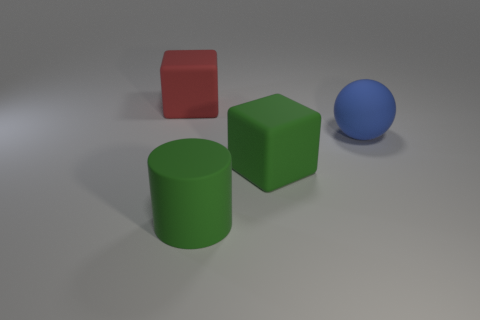What number of blocks are the same color as the large matte cylinder?
Your response must be concise. 1. What number of things are rubber blocks that are right of the red rubber thing or green cubes?
Offer a terse response. 1. What is the color of the ball that is made of the same material as the big green cylinder?
Offer a very short reply. Blue. Is there a cylinder of the same size as the red cube?
Your response must be concise. Yes. What number of things are either large things in front of the big blue rubber ball or big rubber things in front of the red block?
Offer a very short reply. 3. What shape is the green rubber thing that is the same size as the green cube?
Provide a short and direct response. Cylinder. Are there any tiny yellow metal objects that have the same shape as the red thing?
Provide a short and direct response. No. Are there fewer tiny spheres than big matte cubes?
Your answer should be compact. Yes. Is the size of the matte cube that is behind the matte ball the same as the matte thing in front of the big green block?
Make the answer very short. Yes. What number of things are either blue metallic cubes or large green matte cylinders?
Your answer should be very brief. 1. 